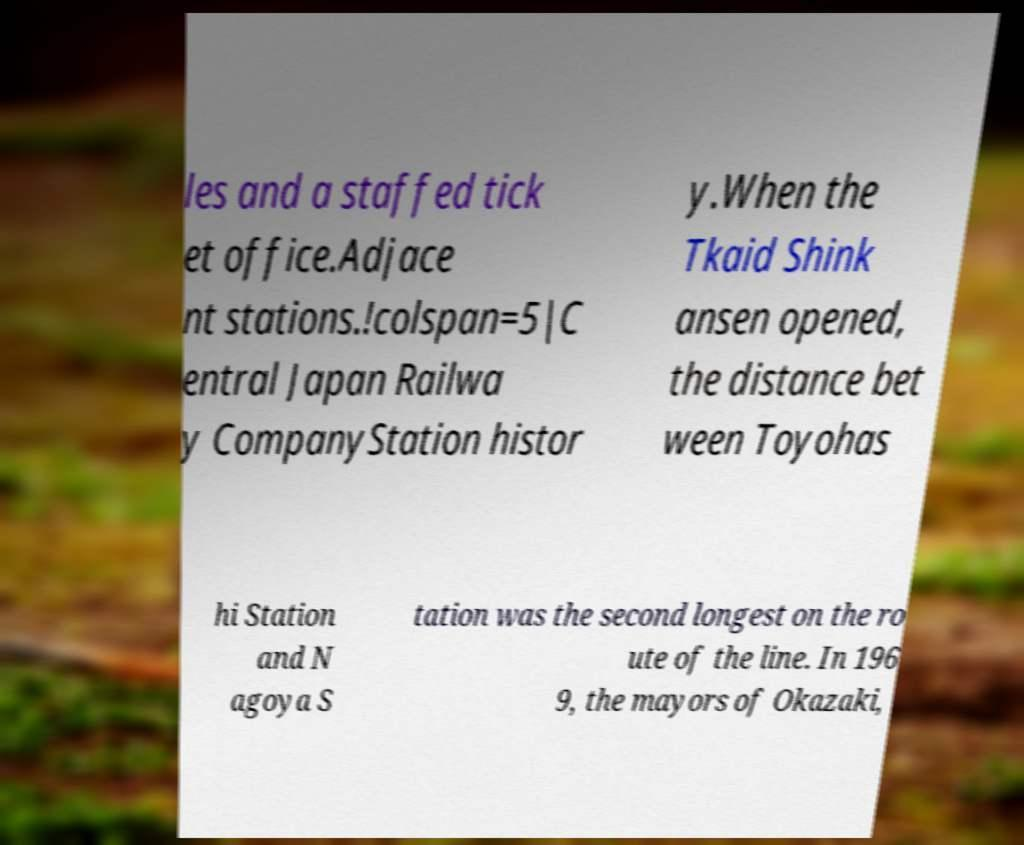For documentation purposes, I need the text within this image transcribed. Could you provide that? les and a staffed tick et office.Adjace nt stations.!colspan=5|C entral Japan Railwa y CompanyStation histor y.When the Tkaid Shink ansen opened, the distance bet ween Toyohas hi Station and N agoya S tation was the second longest on the ro ute of the line. In 196 9, the mayors of Okazaki, 